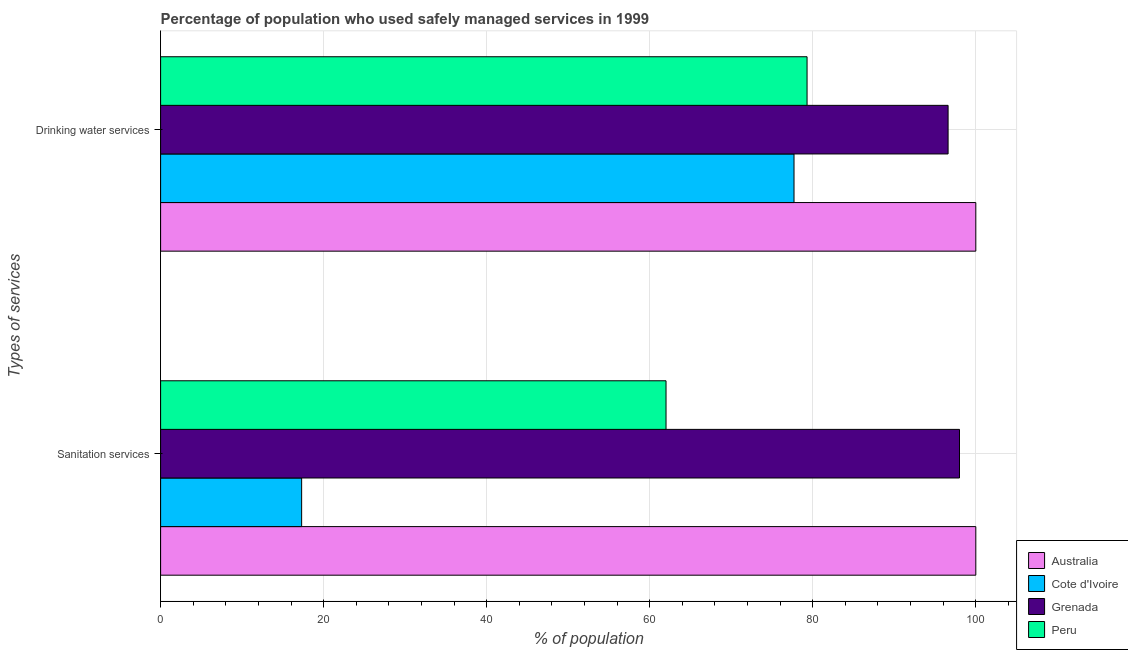How many different coloured bars are there?
Keep it short and to the point. 4. Are the number of bars per tick equal to the number of legend labels?
Provide a succinct answer. Yes. Are the number of bars on each tick of the Y-axis equal?
Your answer should be compact. Yes. How many bars are there on the 2nd tick from the bottom?
Your answer should be very brief. 4. What is the label of the 1st group of bars from the top?
Provide a short and direct response. Drinking water services. Across all countries, what is the maximum percentage of population who used sanitation services?
Provide a succinct answer. 100. In which country was the percentage of population who used drinking water services minimum?
Ensure brevity in your answer.  Cote d'Ivoire. What is the total percentage of population who used drinking water services in the graph?
Your answer should be very brief. 353.6. What is the difference between the percentage of population who used drinking water services in Australia and that in Grenada?
Provide a succinct answer. 3.4. What is the difference between the percentage of population who used drinking water services in Peru and the percentage of population who used sanitation services in Grenada?
Provide a succinct answer. -18.7. What is the average percentage of population who used sanitation services per country?
Provide a succinct answer. 69.33. What is the difference between the percentage of population who used sanitation services and percentage of population who used drinking water services in Grenada?
Offer a very short reply. 1.4. What is the ratio of the percentage of population who used sanitation services in Cote d'Ivoire to that in Australia?
Provide a succinct answer. 0.17. In how many countries, is the percentage of population who used sanitation services greater than the average percentage of population who used sanitation services taken over all countries?
Offer a very short reply. 2. What does the 1st bar from the bottom in Sanitation services represents?
Provide a short and direct response. Australia. How many bars are there?
Give a very brief answer. 8. Are all the bars in the graph horizontal?
Give a very brief answer. Yes. How many countries are there in the graph?
Provide a short and direct response. 4. Are the values on the major ticks of X-axis written in scientific E-notation?
Give a very brief answer. No. Does the graph contain any zero values?
Keep it short and to the point. No. Does the graph contain grids?
Make the answer very short. Yes. Where does the legend appear in the graph?
Your answer should be compact. Bottom right. What is the title of the graph?
Provide a succinct answer. Percentage of population who used safely managed services in 1999. What is the label or title of the X-axis?
Provide a short and direct response. % of population. What is the label or title of the Y-axis?
Keep it short and to the point. Types of services. What is the % of population of Australia in Sanitation services?
Give a very brief answer. 100. What is the % of population in Cote d'Ivoire in Sanitation services?
Make the answer very short. 17.3. What is the % of population of Cote d'Ivoire in Drinking water services?
Offer a very short reply. 77.7. What is the % of population in Grenada in Drinking water services?
Your answer should be very brief. 96.6. What is the % of population of Peru in Drinking water services?
Provide a short and direct response. 79.3. Across all Types of services, what is the maximum % of population in Cote d'Ivoire?
Your answer should be compact. 77.7. Across all Types of services, what is the maximum % of population of Peru?
Ensure brevity in your answer.  79.3. Across all Types of services, what is the minimum % of population of Australia?
Your response must be concise. 100. Across all Types of services, what is the minimum % of population in Grenada?
Provide a short and direct response. 96.6. What is the total % of population in Cote d'Ivoire in the graph?
Provide a succinct answer. 95. What is the total % of population of Grenada in the graph?
Your answer should be very brief. 194.6. What is the total % of population of Peru in the graph?
Give a very brief answer. 141.3. What is the difference between the % of population in Australia in Sanitation services and that in Drinking water services?
Offer a very short reply. 0. What is the difference between the % of population in Cote d'Ivoire in Sanitation services and that in Drinking water services?
Make the answer very short. -60.4. What is the difference between the % of population of Peru in Sanitation services and that in Drinking water services?
Your answer should be very brief. -17.3. What is the difference between the % of population of Australia in Sanitation services and the % of population of Cote d'Ivoire in Drinking water services?
Keep it short and to the point. 22.3. What is the difference between the % of population in Australia in Sanitation services and the % of population in Grenada in Drinking water services?
Offer a terse response. 3.4. What is the difference between the % of population of Australia in Sanitation services and the % of population of Peru in Drinking water services?
Keep it short and to the point. 20.7. What is the difference between the % of population in Cote d'Ivoire in Sanitation services and the % of population in Grenada in Drinking water services?
Your response must be concise. -79.3. What is the difference between the % of population of Cote d'Ivoire in Sanitation services and the % of population of Peru in Drinking water services?
Give a very brief answer. -62. What is the difference between the % of population of Grenada in Sanitation services and the % of population of Peru in Drinking water services?
Offer a terse response. 18.7. What is the average % of population of Cote d'Ivoire per Types of services?
Provide a short and direct response. 47.5. What is the average % of population in Grenada per Types of services?
Provide a succinct answer. 97.3. What is the average % of population of Peru per Types of services?
Ensure brevity in your answer.  70.65. What is the difference between the % of population in Australia and % of population in Cote d'Ivoire in Sanitation services?
Your answer should be very brief. 82.7. What is the difference between the % of population in Cote d'Ivoire and % of population in Grenada in Sanitation services?
Offer a terse response. -80.7. What is the difference between the % of population of Cote d'Ivoire and % of population of Peru in Sanitation services?
Ensure brevity in your answer.  -44.7. What is the difference between the % of population in Australia and % of population in Cote d'Ivoire in Drinking water services?
Your answer should be compact. 22.3. What is the difference between the % of population of Australia and % of population of Grenada in Drinking water services?
Offer a very short reply. 3.4. What is the difference between the % of population of Australia and % of population of Peru in Drinking water services?
Ensure brevity in your answer.  20.7. What is the difference between the % of population in Cote d'Ivoire and % of population in Grenada in Drinking water services?
Offer a very short reply. -18.9. What is the ratio of the % of population in Australia in Sanitation services to that in Drinking water services?
Provide a succinct answer. 1. What is the ratio of the % of population of Cote d'Ivoire in Sanitation services to that in Drinking water services?
Offer a terse response. 0.22. What is the ratio of the % of population of Grenada in Sanitation services to that in Drinking water services?
Your answer should be compact. 1.01. What is the ratio of the % of population of Peru in Sanitation services to that in Drinking water services?
Your answer should be compact. 0.78. What is the difference between the highest and the second highest % of population in Cote d'Ivoire?
Keep it short and to the point. 60.4. What is the difference between the highest and the second highest % of population of Grenada?
Keep it short and to the point. 1.4. What is the difference between the highest and the lowest % of population of Australia?
Your response must be concise. 0. What is the difference between the highest and the lowest % of population in Cote d'Ivoire?
Your answer should be very brief. 60.4. What is the difference between the highest and the lowest % of population in Peru?
Your response must be concise. 17.3. 